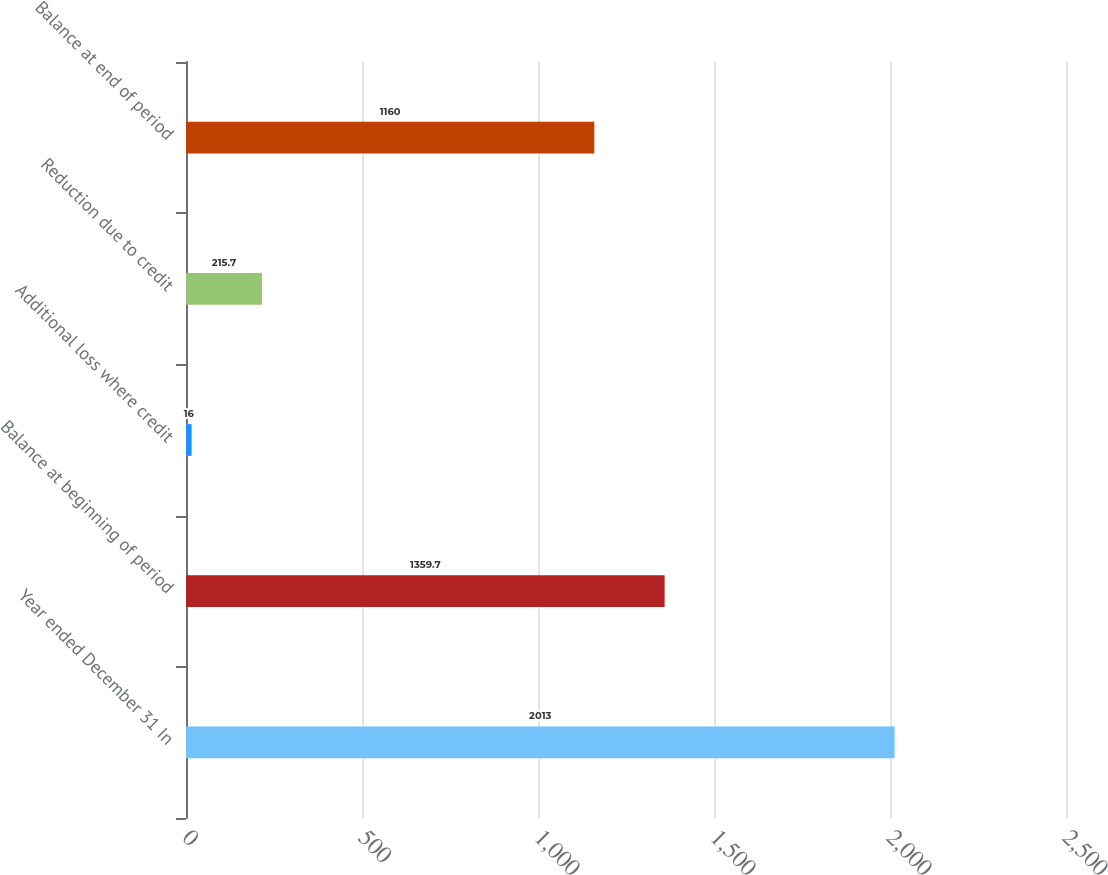Convert chart. <chart><loc_0><loc_0><loc_500><loc_500><bar_chart><fcel>Year ended December 31 In<fcel>Balance at beginning of period<fcel>Additional loss where credit<fcel>Reduction due to credit<fcel>Balance at end of period<nl><fcel>2013<fcel>1359.7<fcel>16<fcel>215.7<fcel>1160<nl></chart> 